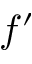<formula> <loc_0><loc_0><loc_500><loc_500>f ^ { \prime }</formula> 